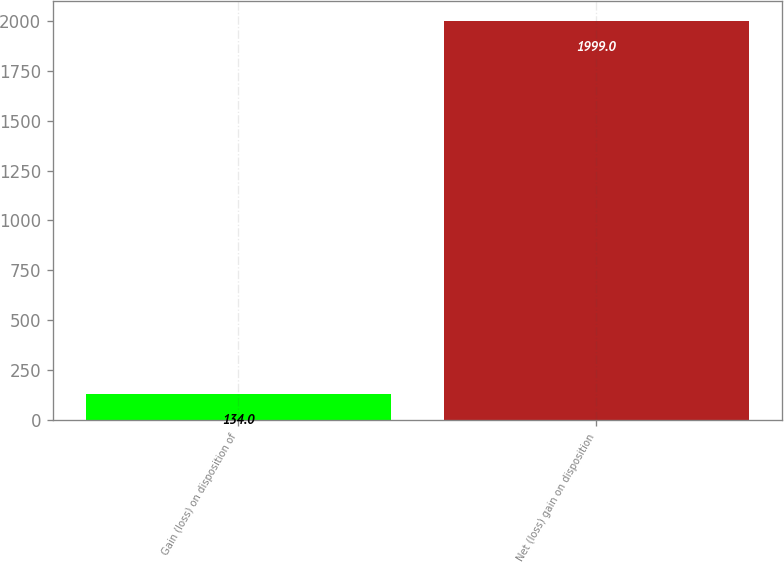Convert chart. <chart><loc_0><loc_0><loc_500><loc_500><bar_chart><fcel>Gain (loss) on disposition of<fcel>Net (loss) gain on disposition<nl><fcel>134<fcel>1999<nl></chart> 